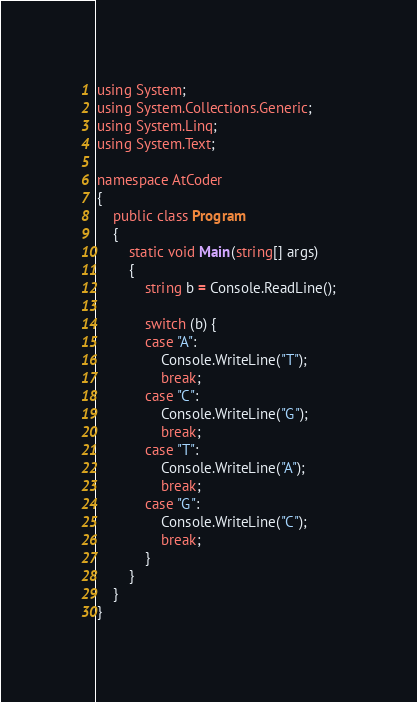Convert code to text. <code><loc_0><loc_0><loc_500><loc_500><_C#_>using System;
using System.Collections.Generic;
using System.Linq;
using System.Text;

namespace AtCoder
{
	public class Program
	{
		static void Main(string[] args)
		{
			string b = Console.ReadLine();

			switch (b) {
			case "A":
				Console.WriteLine("T");
				break;
			case "C":
				Console.WriteLine("G");
				break;
			case "T":
				Console.WriteLine("A");
				break;
			case "G":
				Console.WriteLine("C");
				break;
			}
		}
	}
}</code> 